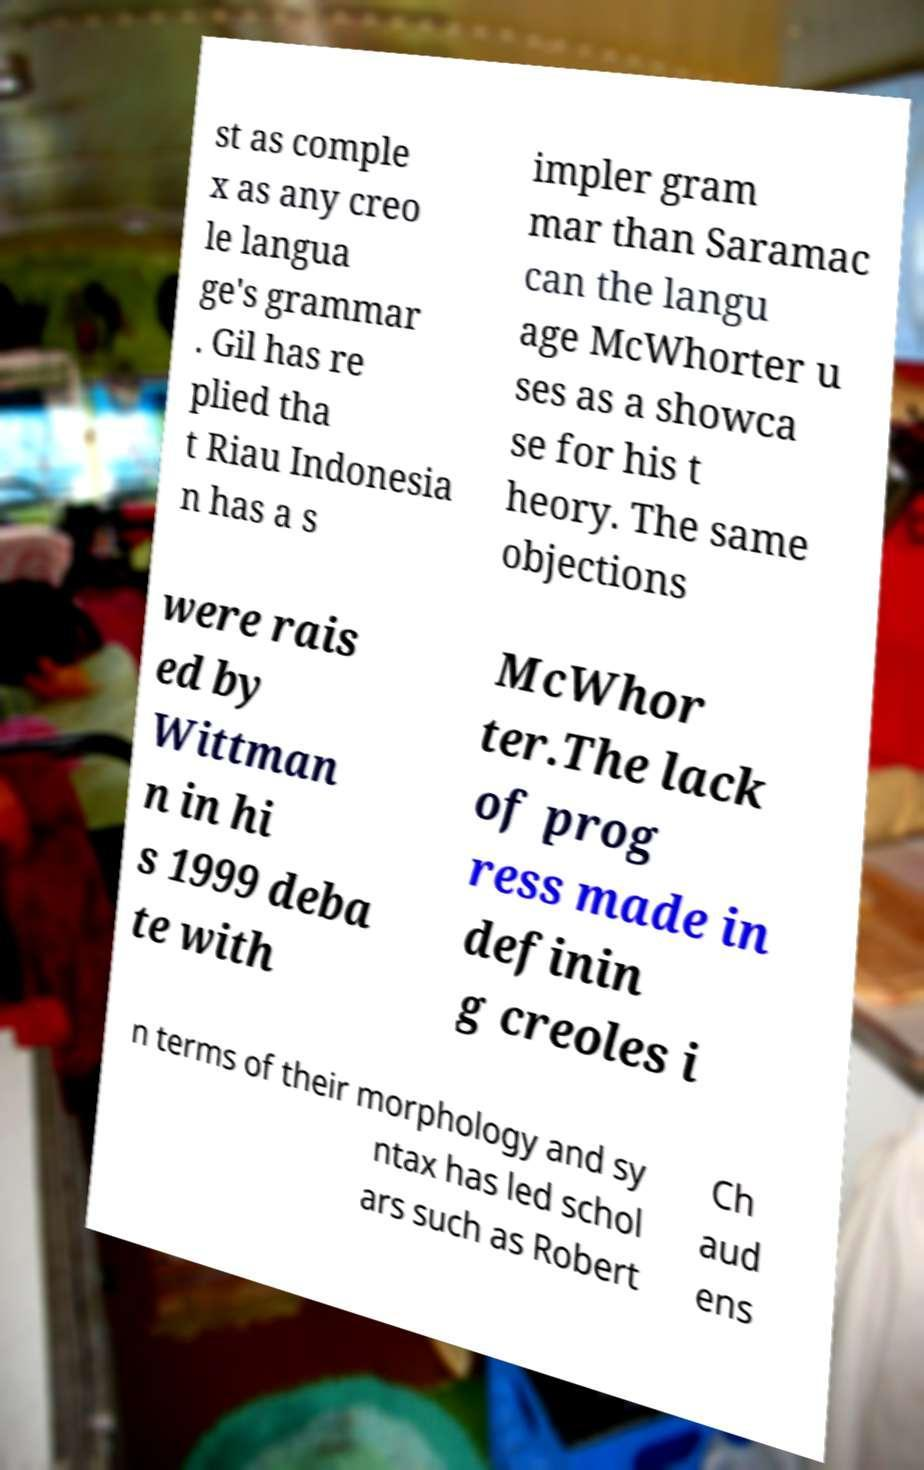Please read and relay the text visible in this image. What does it say? st as comple x as any creo le langua ge's grammar . Gil has re plied tha t Riau Indonesia n has a s impler gram mar than Saramac can the langu age McWhorter u ses as a showca se for his t heory. The same objections were rais ed by Wittman n in hi s 1999 deba te with McWhor ter.The lack of prog ress made in definin g creoles i n terms of their morphology and sy ntax has led schol ars such as Robert Ch aud ens 